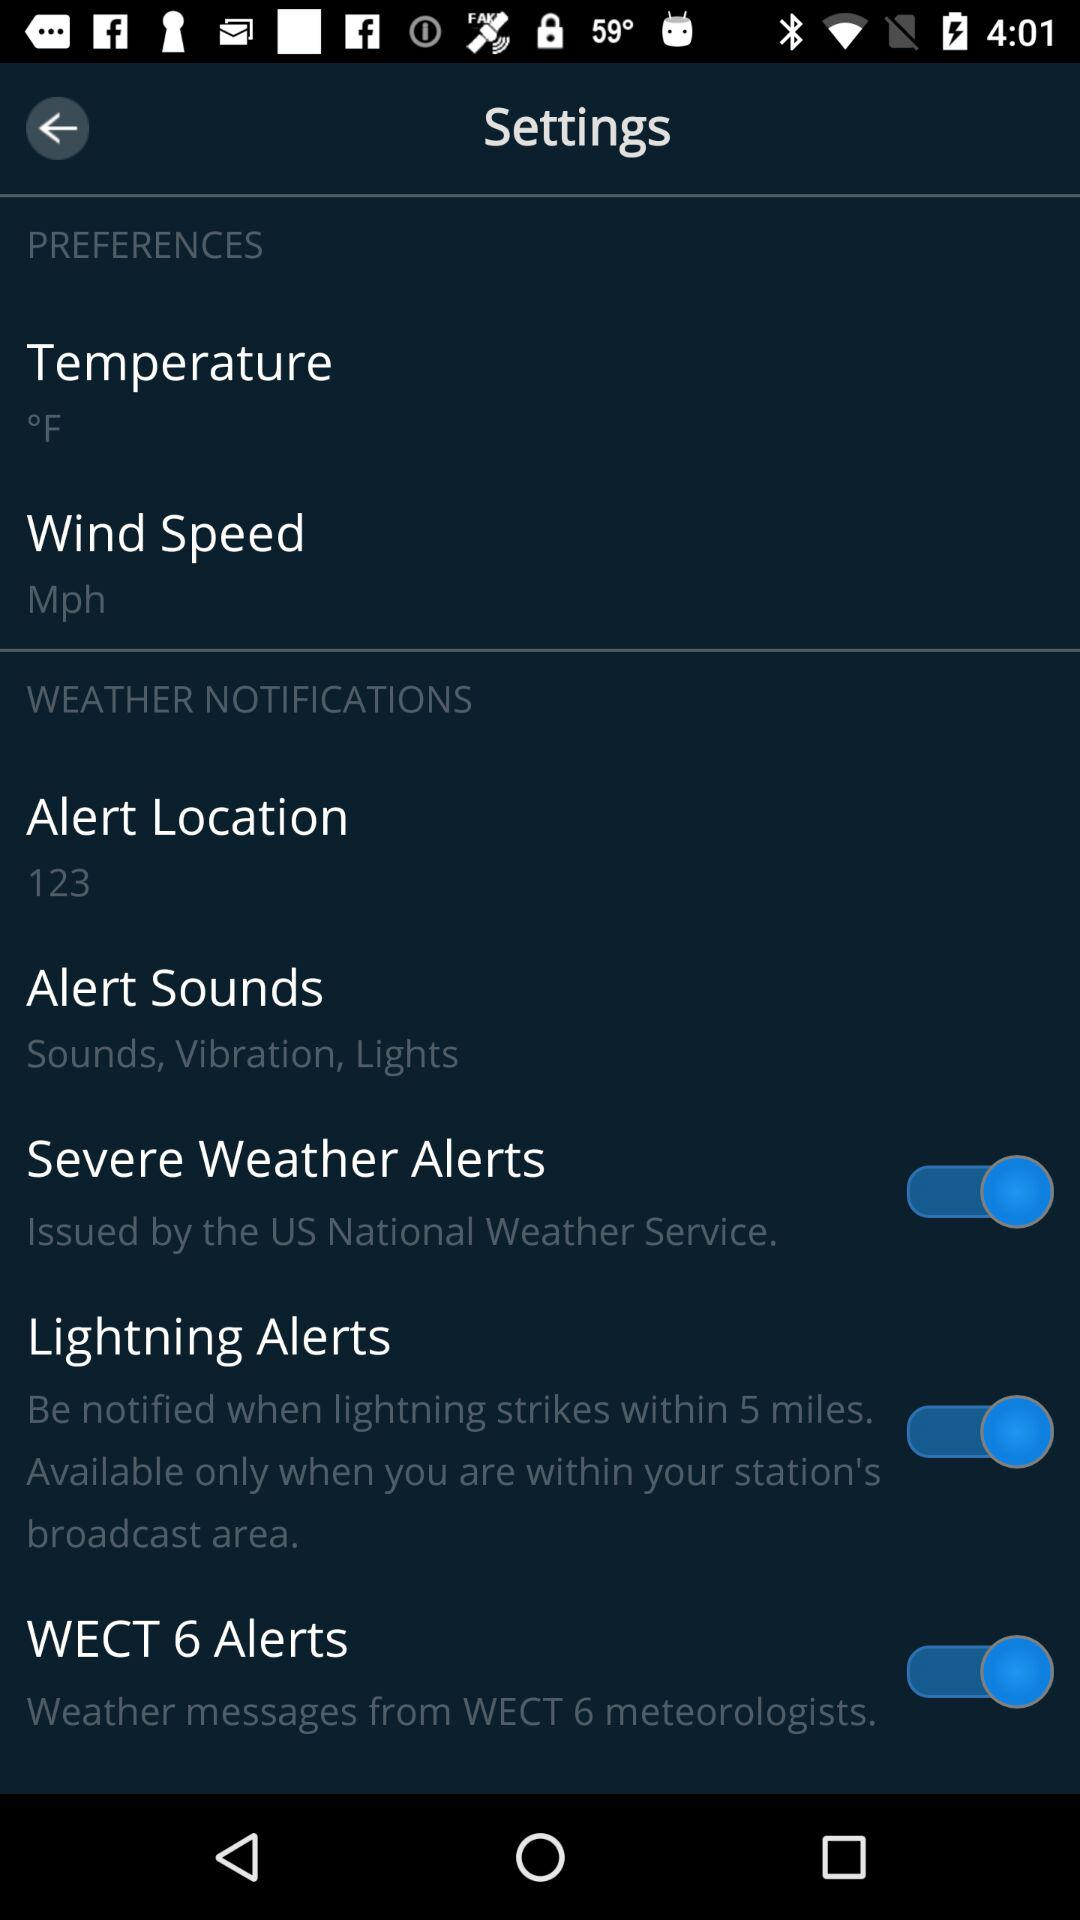What is the unit of temperature? The unit of temperature is degrees Fahrenheit. 